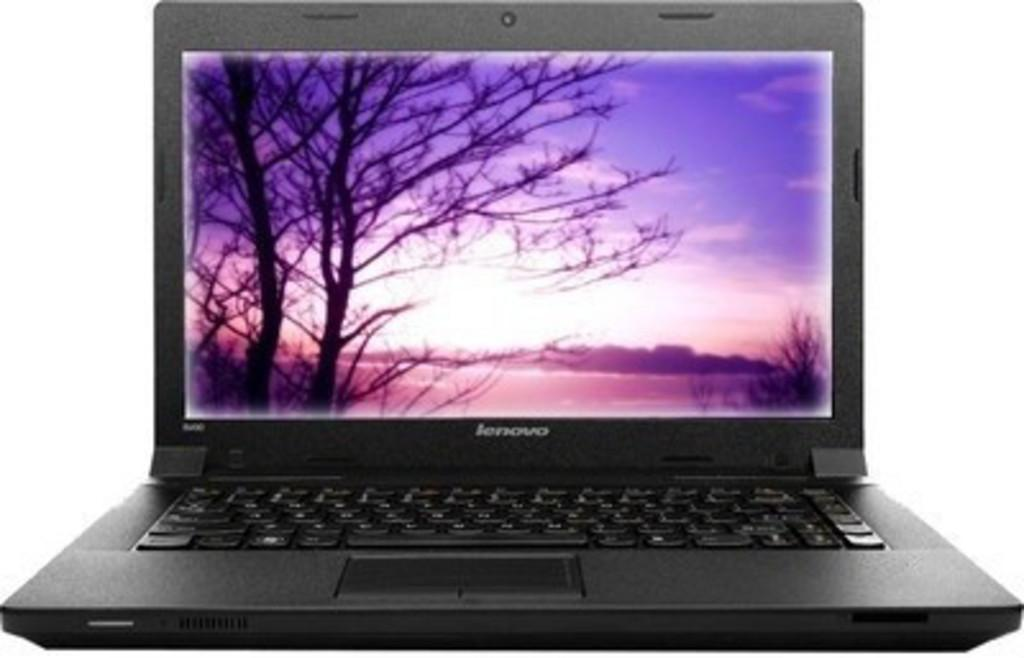What electronic device is visible in the image? There is a laptop in the image. What feature is present on the laptop? The laptop has a screen. What color is the background of the image? The background of the image is white in color. What is the taste of the ant crawling on the laptop in the image? There is no ant present in the image, so it is not possible to determine its taste. 